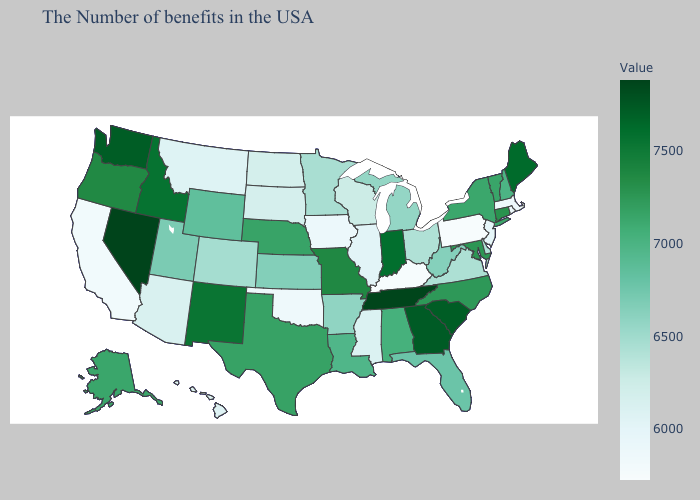Which states have the lowest value in the USA?
Concise answer only. Pennsylvania. Does Hawaii have the lowest value in the USA?
Answer briefly. No. Among the states that border Vermont , which have the lowest value?
Concise answer only. Massachusetts. Does Nevada have the highest value in the USA?
Write a very short answer. Yes. Which states hav the highest value in the MidWest?
Quick response, please. Indiana. Is the legend a continuous bar?
Quick response, please. Yes. Which states have the highest value in the USA?
Concise answer only. Nevada. 